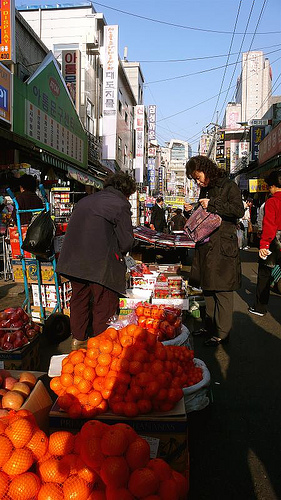What types of fruits and vegetables can you see in the image besides oranges? Besides oranges, the market also displays apples, bananas, tomatoes, and leafy greens. Each variety brings a splash of color and indicates a rich selection available for the market visitors. 